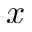<formula> <loc_0><loc_0><loc_500><loc_500>x</formula> 